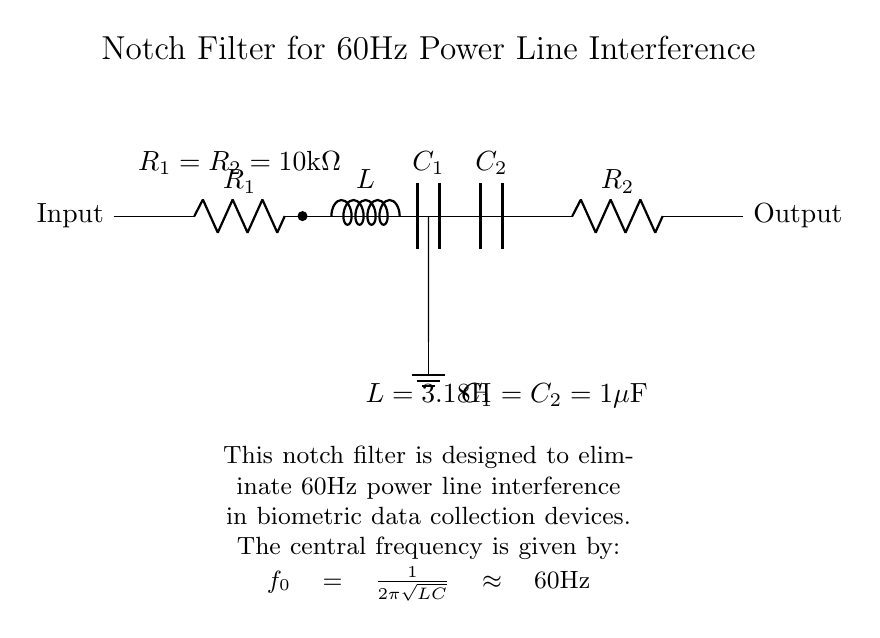What components are used in the circuit? The circuit contains a resistor, capacitor, and inductor. Specifically, there are two resistors (R1 and R2), two capacitors (C1 and C2), and one inductor (L).
Answer: Resistor, capacitor, inductor What is the value of R1? The diagram specifies that R1 has a resistance value of 10k ohms.
Answer: 10k ohms What is the purpose of this notch filter? The primary purpose of the notch filter is to eliminate 60Hz power line interference, which is common in biometric data collection devices.
Answer: Eliminate 60Hz interference What is the central frequency of the notch filter? The central frequency is calculated using the formula for resonance, which, for this circuit, results in approximately 60Hz.
Answer: 60Hz Why are R1 and R2 equal? Both resistors are set to the same value to maintain the filter's characteristics, ensuring symmetry in the circuit design and optimal performance in eliminating the targeted frequency.
Answer: To maintain symmetry What happens to signals not at 60Hz? Signals that are not at the notch frequency will pass through unaffected, while the 60Hz signal is attenuated significantly, reducing its interference in the output.
Answer: They pass through unaffected What is the significance of the ground in the circuit? The ground serves as a reference point for the voltages in the circuit; it ensures stability and safety by providing a common return path for current.
Answer: Reference point for voltage 